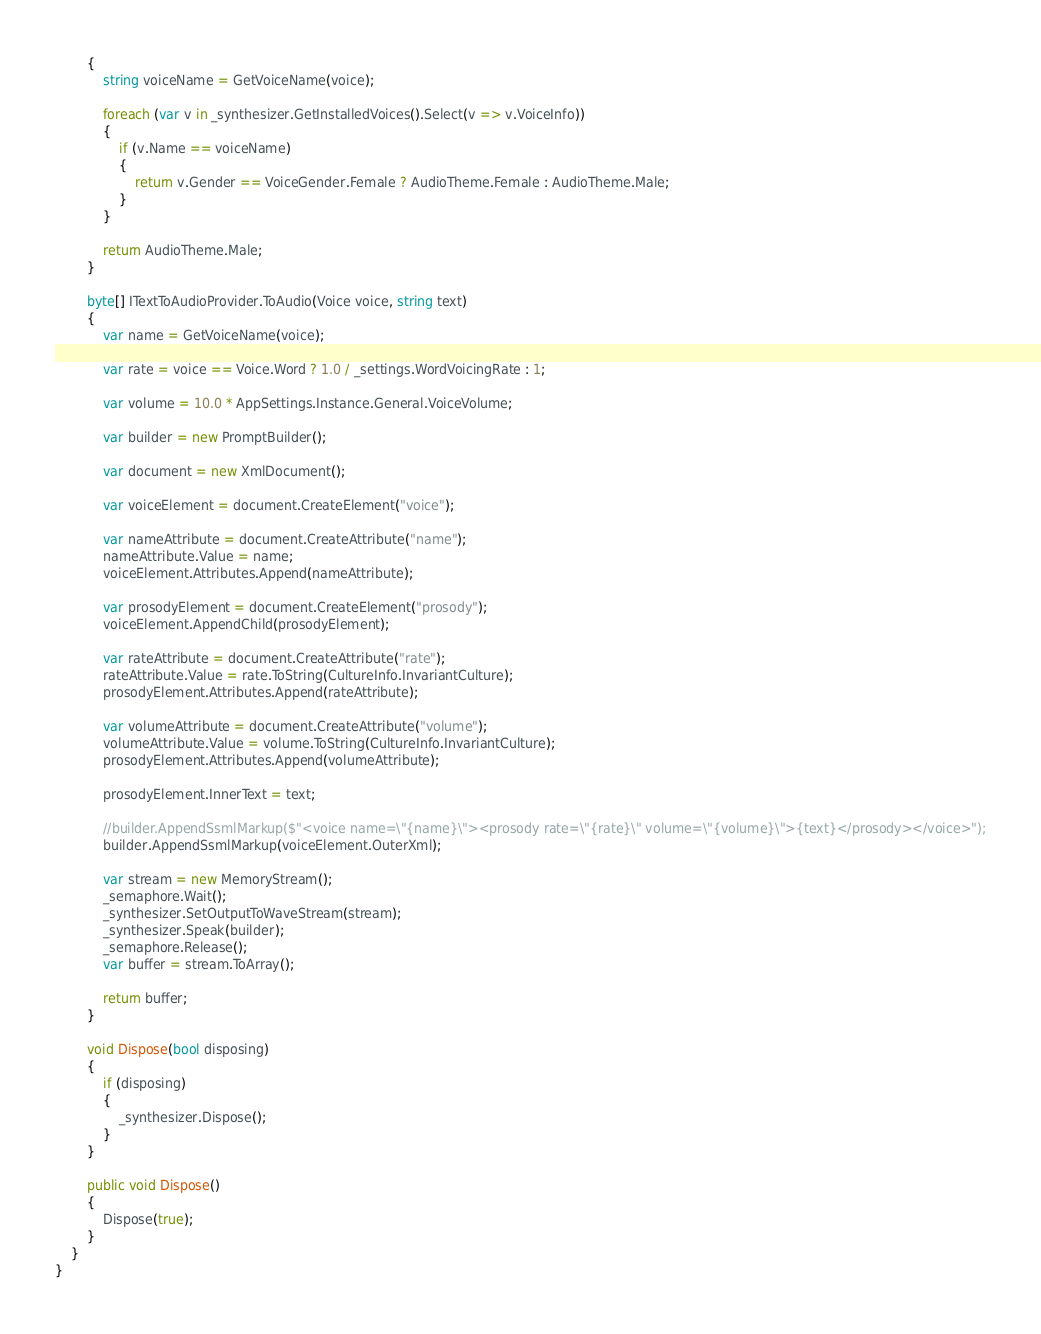<code> <loc_0><loc_0><loc_500><loc_500><_C#_>        {
            string voiceName = GetVoiceName(voice);

            foreach (var v in _synthesizer.GetInstalledVoices().Select(v => v.VoiceInfo))
            {
                if (v.Name == voiceName)
                {
                    return v.Gender == VoiceGender.Female ? AudioTheme.Female : AudioTheme.Male;
                }
            }

            return AudioTheme.Male;
        }

        byte[] ITextToAudioProvider.ToAudio(Voice voice, string text)
        {
            var name = GetVoiceName(voice);

            var rate = voice == Voice.Word ? 1.0 / _settings.WordVoicingRate : 1;

            var volume = 10.0 * AppSettings.Instance.General.VoiceVolume;

            var builder = new PromptBuilder();

            var document = new XmlDocument();

            var voiceElement = document.CreateElement("voice");

            var nameAttribute = document.CreateAttribute("name");
            nameAttribute.Value = name;
            voiceElement.Attributes.Append(nameAttribute);

            var prosodyElement = document.CreateElement("prosody");
            voiceElement.AppendChild(prosodyElement);

            var rateAttribute = document.CreateAttribute("rate");
            rateAttribute.Value = rate.ToString(CultureInfo.InvariantCulture);
            prosodyElement.Attributes.Append(rateAttribute);

            var volumeAttribute = document.CreateAttribute("volume");
            volumeAttribute.Value = volume.ToString(CultureInfo.InvariantCulture);
            prosodyElement.Attributes.Append(volumeAttribute);

            prosodyElement.InnerText = text;

            //builder.AppendSsmlMarkup($"<voice name=\"{name}\"><prosody rate=\"{rate}\" volume=\"{volume}\">{text}</prosody></voice>");
            builder.AppendSsmlMarkup(voiceElement.OuterXml);

            var stream = new MemoryStream();
            _semaphore.Wait();
            _synthesizer.SetOutputToWaveStream(stream);
            _synthesizer.Speak(builder);
            _semaphore.Release();
            var buffer = stream.ToArray();

            return buffer;
        }

        void Dispose(bool disposing)
        {
            if (disposing)
            {
                _synthesizer.Dispose();
            }
        }

        public void Dispose()
        {
            Dispose(true);
        }
    }
}
</code> 